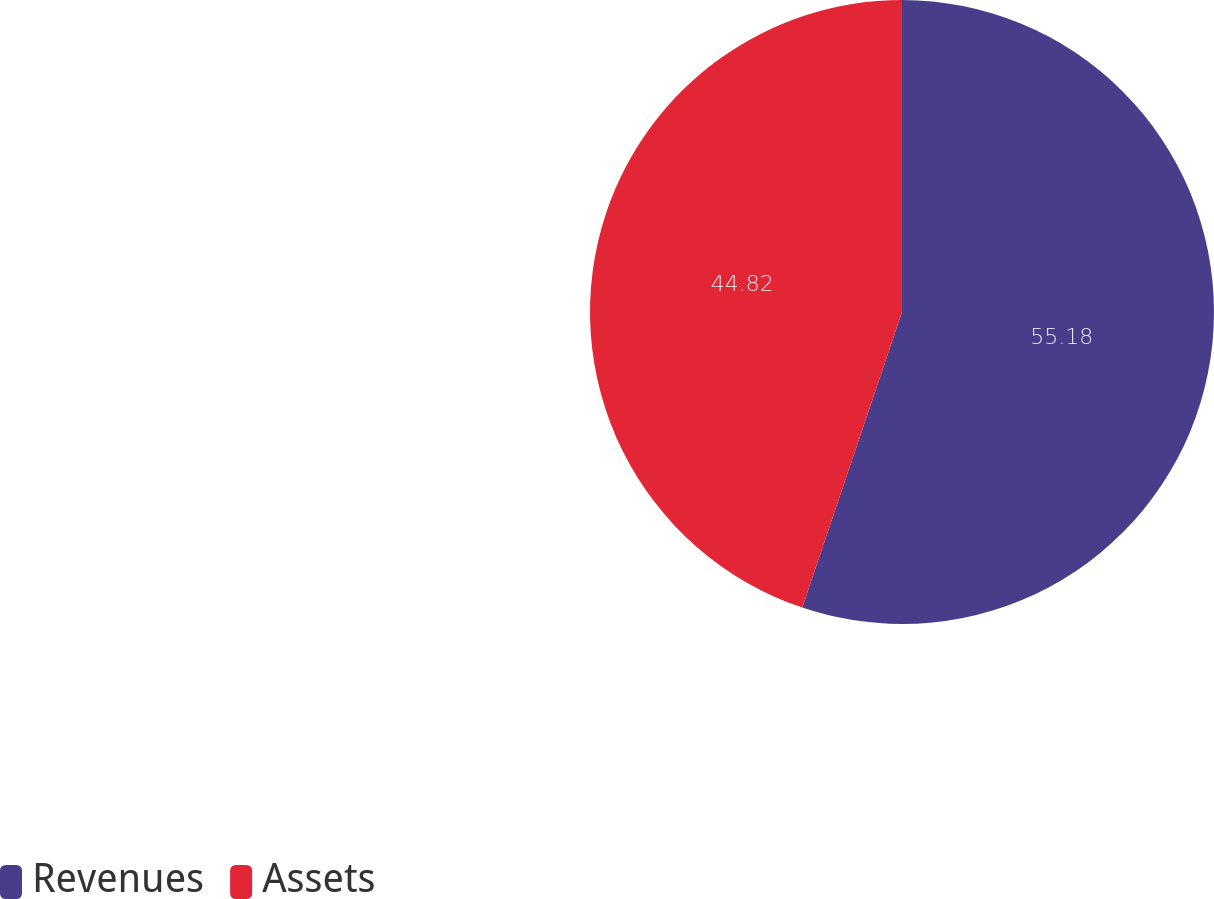<chart> <loc_0><loc_0><loc_500><loc_500><pie_chart><fcel>Revenues<fcel>Assets<nl><fcel>55.18%<fcel>44.82%<nl></chart> 